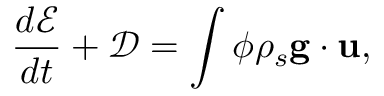Convert formula to latex. <formula><loc_0><loc_0><loc_500><loc_500>\frac { d \mathcal { E } } { d t } + \mathcal { D } = \int \phi \rho _ { s } { g } \cdot { u } ,</formula> 